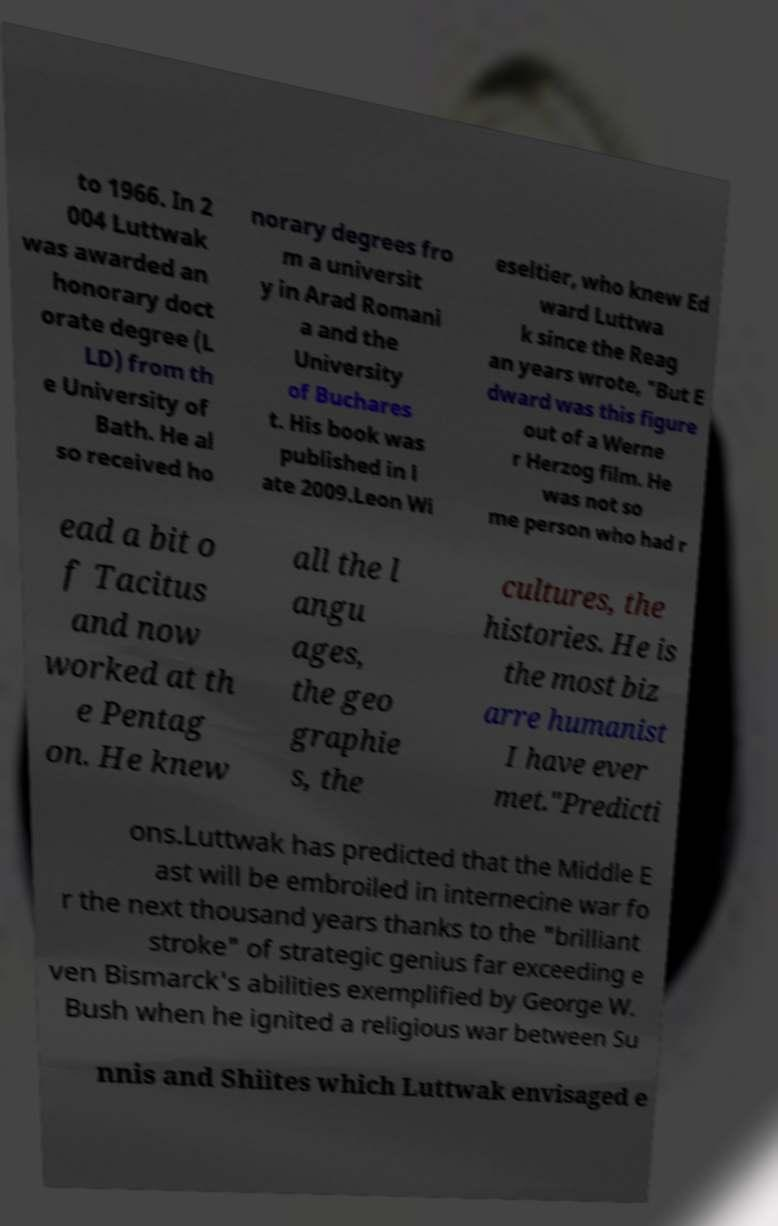Can you read and provide the text displayed in the image?This photo seems to have some interesting text. Can you extract and type it out for me? to 1966. In 2 004 Luttwak was awarded an honorary doct orate degree (L LD) from th e University of Bath. He al so received ho norary degrees fro m a universit y in Arad Romani a and the University of Buchares t. His book was published in l ate 2009.Leon Wi eseltier, who knew Ed ward Luttwa k since the Reag an years wrote, "But E dward was this figure out of a Werne r Herzog film. He was not so me person who had r ead a bit o f Tacitus and now worked at th e Pentag on. He knew all the l angu ages, the geo graphie s, the cultures, the histories. He is the most biz arre humanist I have ever met."Predicti ons.Luttwak has predicted that the Middle E ast will be embroiled in internecine war fo r the next thousand years thanks to the "brilliant stroke" of strategic genius far exceeding e ven Bismarck's abilities exemplified by George W. Bush when he ignited a religious war between Su nnis and Shiites which Luttwak envisaged e 